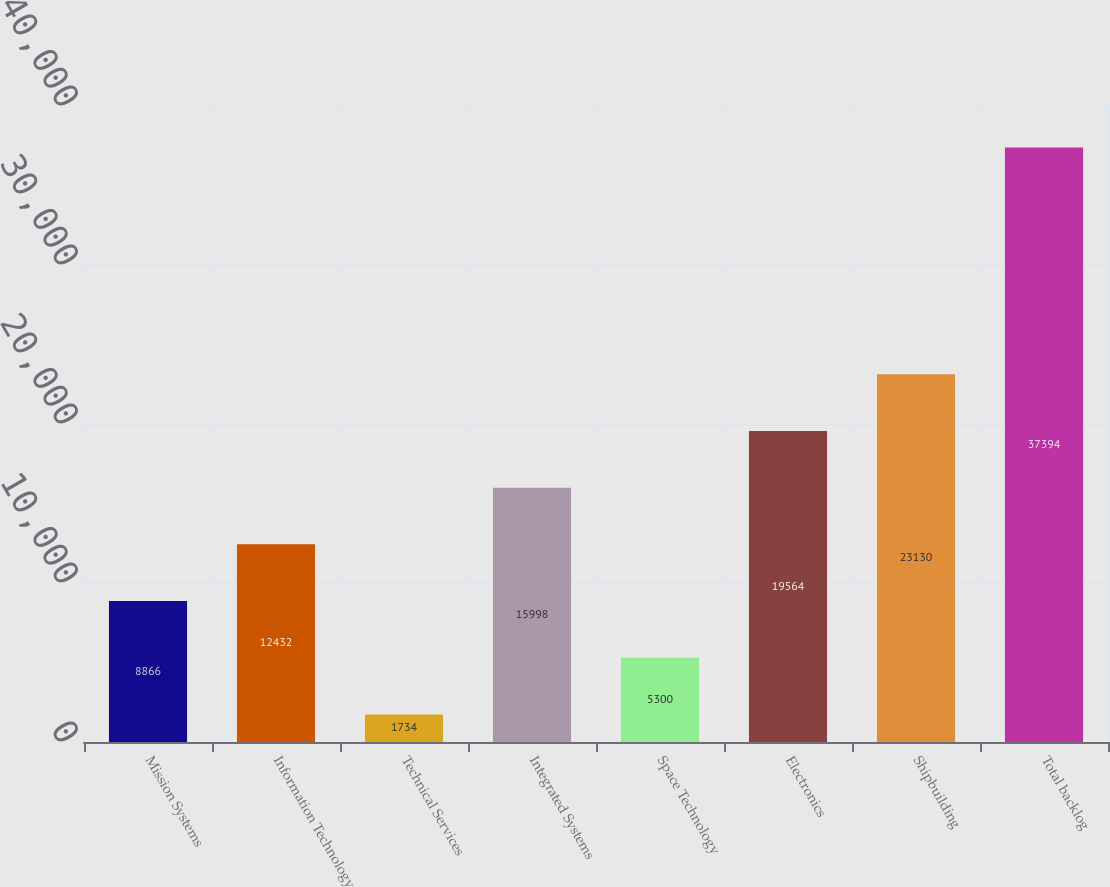<chart> <loc_0><loc_0><loc_500><loc_500><bar_chart><fcel>Mission Systems<fcel>Information Technology<fcel>Technical Services<fcel>Integrated Systems<fcel>Space Technology<fcel>Electronics<fcel>Shipbuilding<fcel>Total backlog<nl><fcel>8866<fcel>12432<fcel>1734<fcel>15998<fcel>5300<fcel>19564<fcel>23130<fcel>37394<nl></chart> 